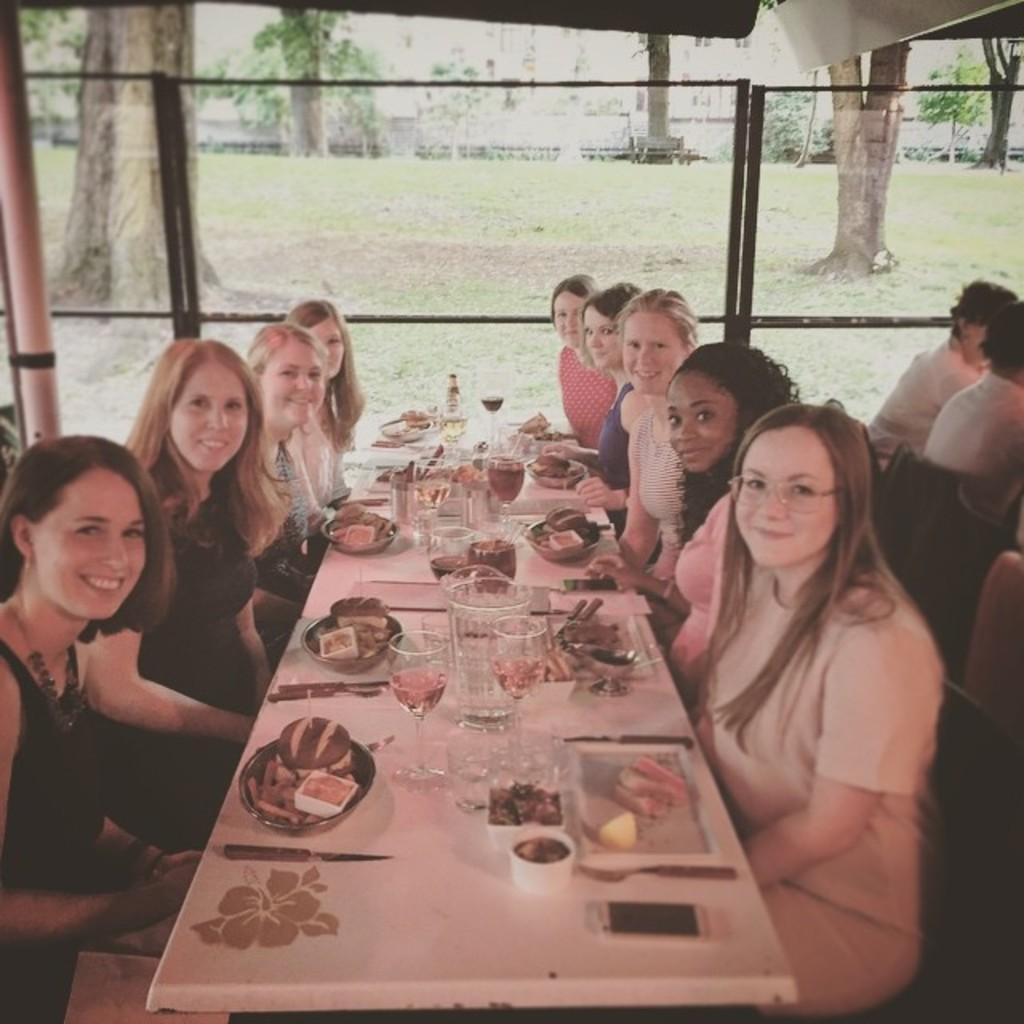Describe this image in one or two sentences. In this image there are group of woman sitting in chair near the table and in table there is knife , fork, mobile , cup, food, jug, glass , a bottle ,and in back ground there are group of persons sitting in chair , tree, grass , plants. 